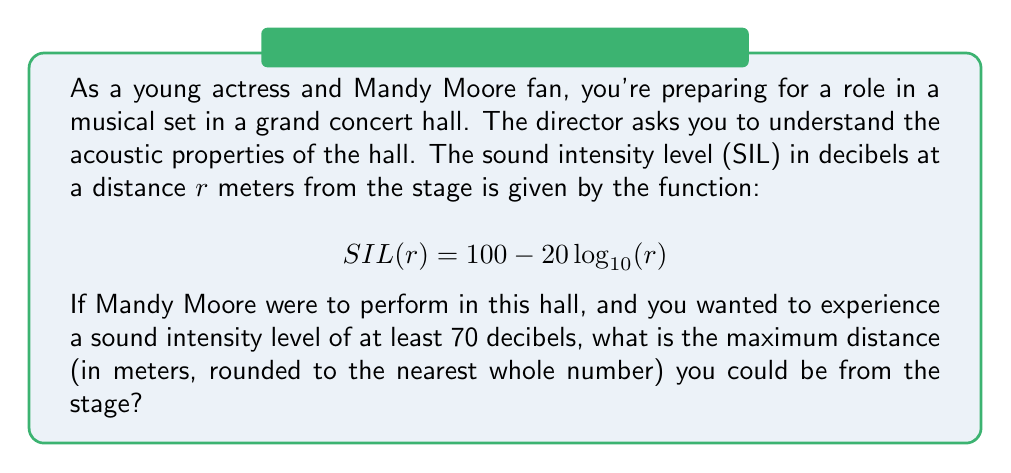Can you answer this question? To solve this problem, we need to use the given exponential function and work backwards to find the maximum distance for a given sound intensity level.

1) We want to find $r$ when $SIL(r) = 70$ decibels. Let's set up the equation:

   $$70 = 100 - 20\log_{10}(r)$$

2) Subtract 100 from both sides:

   $$-30 = -20\log_{10}(r)$$

3) Divide both sides by -20:

   $$1.5 = \log_{10}(r)$$

4) To solve for $r$, we need to apply the inverse function of $\log_{10}$, which is $10^x$:

   $$10^{1.5} = r$$

5) Calculate this value:

   $$r = 10^{1.5} \approx 31.62277$$

6) Rounding to the nearest whole number:

   $$r \approx 32$$

Therefore, the maximum distance you could be from the stage while still experiencing a sound intensity level of at least 70 decibels is 32 meters.
Answer: 32 meters 